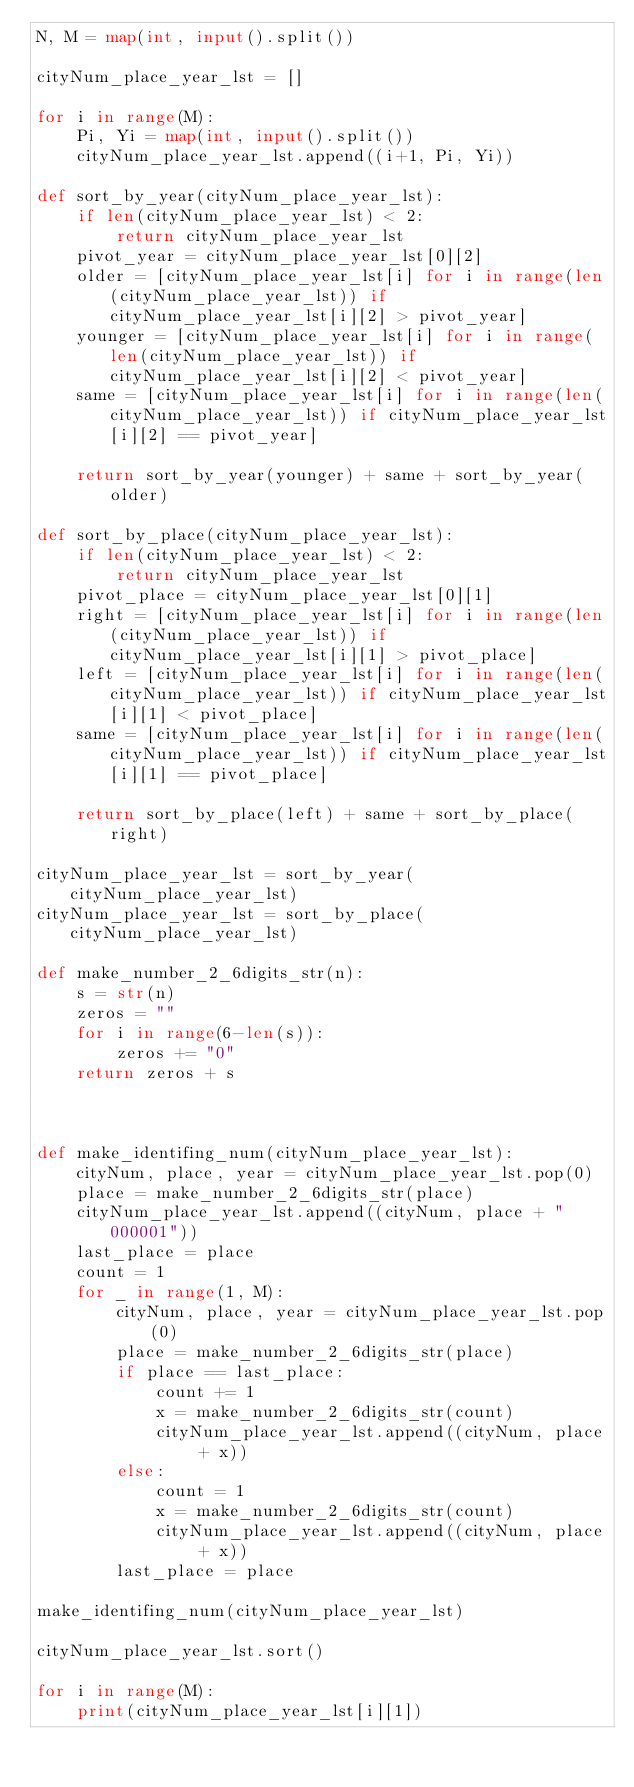Convert code to text. <code><loc_0><loc_0><loc_500><loc_500><_Python_>N, M = map(int, input().split())

cityNum_place_year_lst = []

for i in range(M):
    Pi, Yi = map(int, input().split())
    cityNum_place_year_lst.append((i+1, Pi, Yi))

def sort_by_year(cityNum_place_year_lst):
    if len(cityNum_place_year_lst) < 2:
        return cityNum_place_year_lst
    pivot_year = cityNum_place_year_lst[0][2]
    older = [cityNum_place_year_lst[i] for i in range(len(cityNum_place_year_lst)) if cityNum_place_year_lst[i][2] > pivot_year]
    younger = [cityNum_place_year_lst[i] for i in range(len(cityNum_place_year_lst)) if cityNum_place_year_lst[i][2] < pivot_year]
    same = [cityNum_place_year_lst[i] for i in range(len(cityNum_place_year_lst)) if cityNum_place_year_lst[i][2] == pivot_year]

    return sort_by_year(younger) + same + sort_by_year(older)

def sort_by_place(cityNum_place_year_lst):
    if len(cityNum_place_year_lst) < 2:
        return cityNum_place_year_lst
    pivot_place = cityNum_place_year_lst[0][1]
    right = [cityNum_place_year_lst[i] for i in range(len(cityNum_place_year_lst)) if cityNum_place_year_lst[i][1] > pivot_place]
    left = [cityNum_place_year_lst[i] for i in range(len(cityNum_place_year_lst)) if cityNum_place_year_lst[i][1] < pivot_place]
    same = [cityNum_place_year_lst[i] for i in range(len(cityNum_place_year_lst)) if cityNum_place_year_lst[i][1] == pivot_place]

    return sort_by_place(left) + same + sort_by_place(right)

cityNum_place_year_lst = sort_by_year(cityNum_place_year_lst)
cityNum_place_year_lst = sort_by_place(cityNum_place_year_lst)

def make_number_2_6digits_str(n):
    s = str(n)
    zeros = ""
    for i in range(6-len(s)):
        zeros += "0"
    return zeros + s



def make_identifing_num(cityNum_place_year_lst):
    cityNum, place, year = cityNum_place_year_lst.pop(0)
    place = make_number_2_6digits_str(place)
    cityNum_place_year_lst.append((cityNum, place + "000001"))
    last_place = place
    count = 1
    for _ in range(1, M):
        cityNum, place, year = cityNum_place_year_lst.pop(0)
        place = make_number_2_6digits_str(place)
        if place == last_place:
            count += 1
            x = make_number_2_6digits_str(count)
            cityNum_place_year_lst.append((cityNum, place + x))
        else:
            count = 1
            x = make_number_2_6digits_str(count)
            cityNum_place_year_lst.append((cityNum, place + x))
        last_place = place

make_identifing_num(cityNum_place_year_lst)

cityNum_place_year_lst.sort()

for i in range(M):
    print(cityNum_place_year_lst[i][1])</code> 